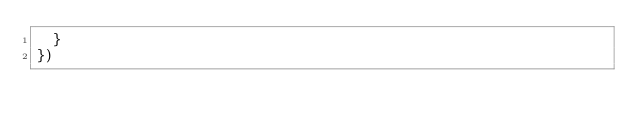Convert code to text. <code><loc_0><loc_0><loc_500><loc_500><_JavaScript_>  }
})
</code> 